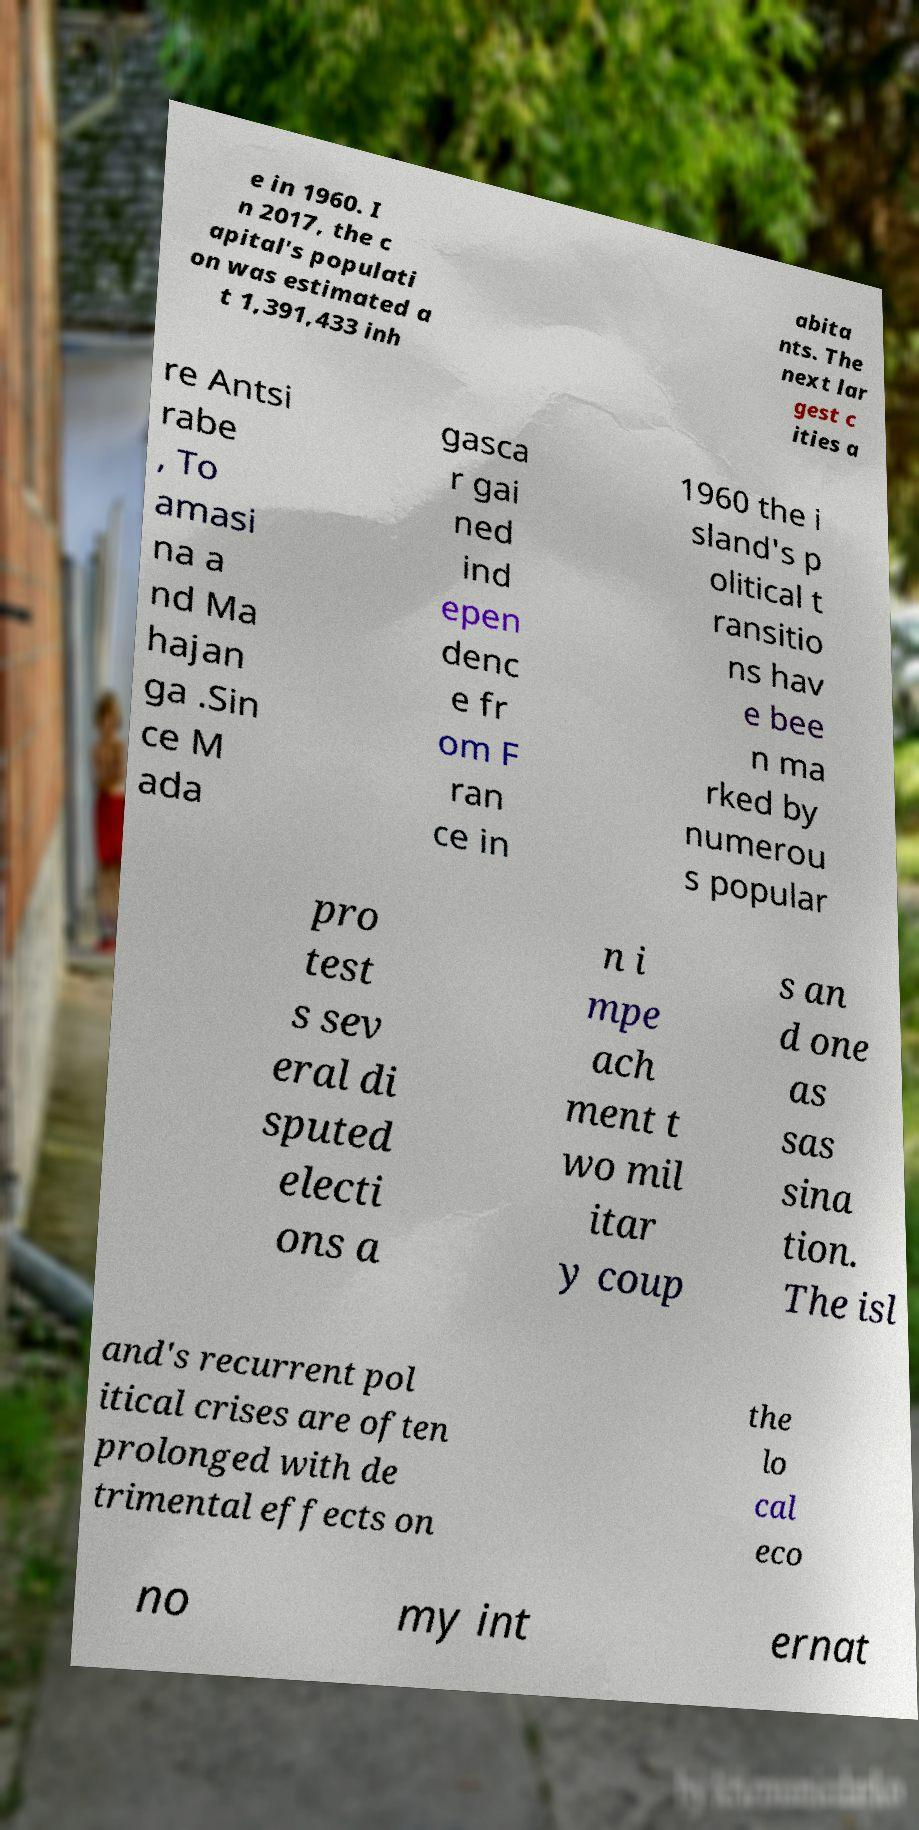Can you read and provide the text displayed in the image?This photo seems to have some interesting text. Can you extract and type it out for me? e in 1960. I n 2017, the c apital's populati on was estimated a t 1,391,433 inh abita nts. The next lar gest c ities a re Antsi rabe , To amasi na a nd Ma hajan ga .Sin ce M ada gasca r gai ned ind epen denc e fr om F ran ce in 1960 the i sland's p olitical t ransitio ns hav e bee n ma rked by numerou s popular pro test s sev eral di sputed electi ons a n i mpe ach ment t wo mil itar y coup s an d one as sas sina tion. The isl and's recurrent pol itical crises are often prolonged with de trimental effects on the lo cal eco no my int ernat 